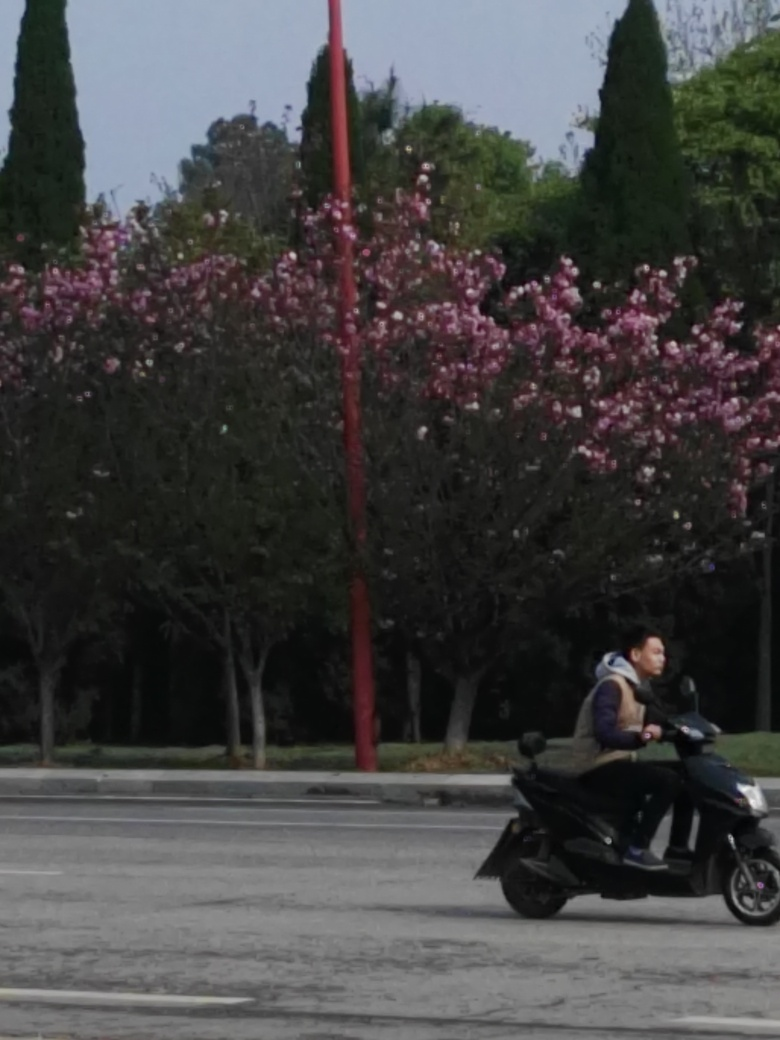Is there activity in this image that suggests a particular time of day? While there are no explicit indicators of the exact time, the low activity level on the street and the quality of the natural light suggest it could be either early in the morning, when traffic is usually lighter, or possibly during a time of day when the streets are less busy. The light is soft and diffuse, which is typical for mornings or late afternoons, especially under overcast conditions. 